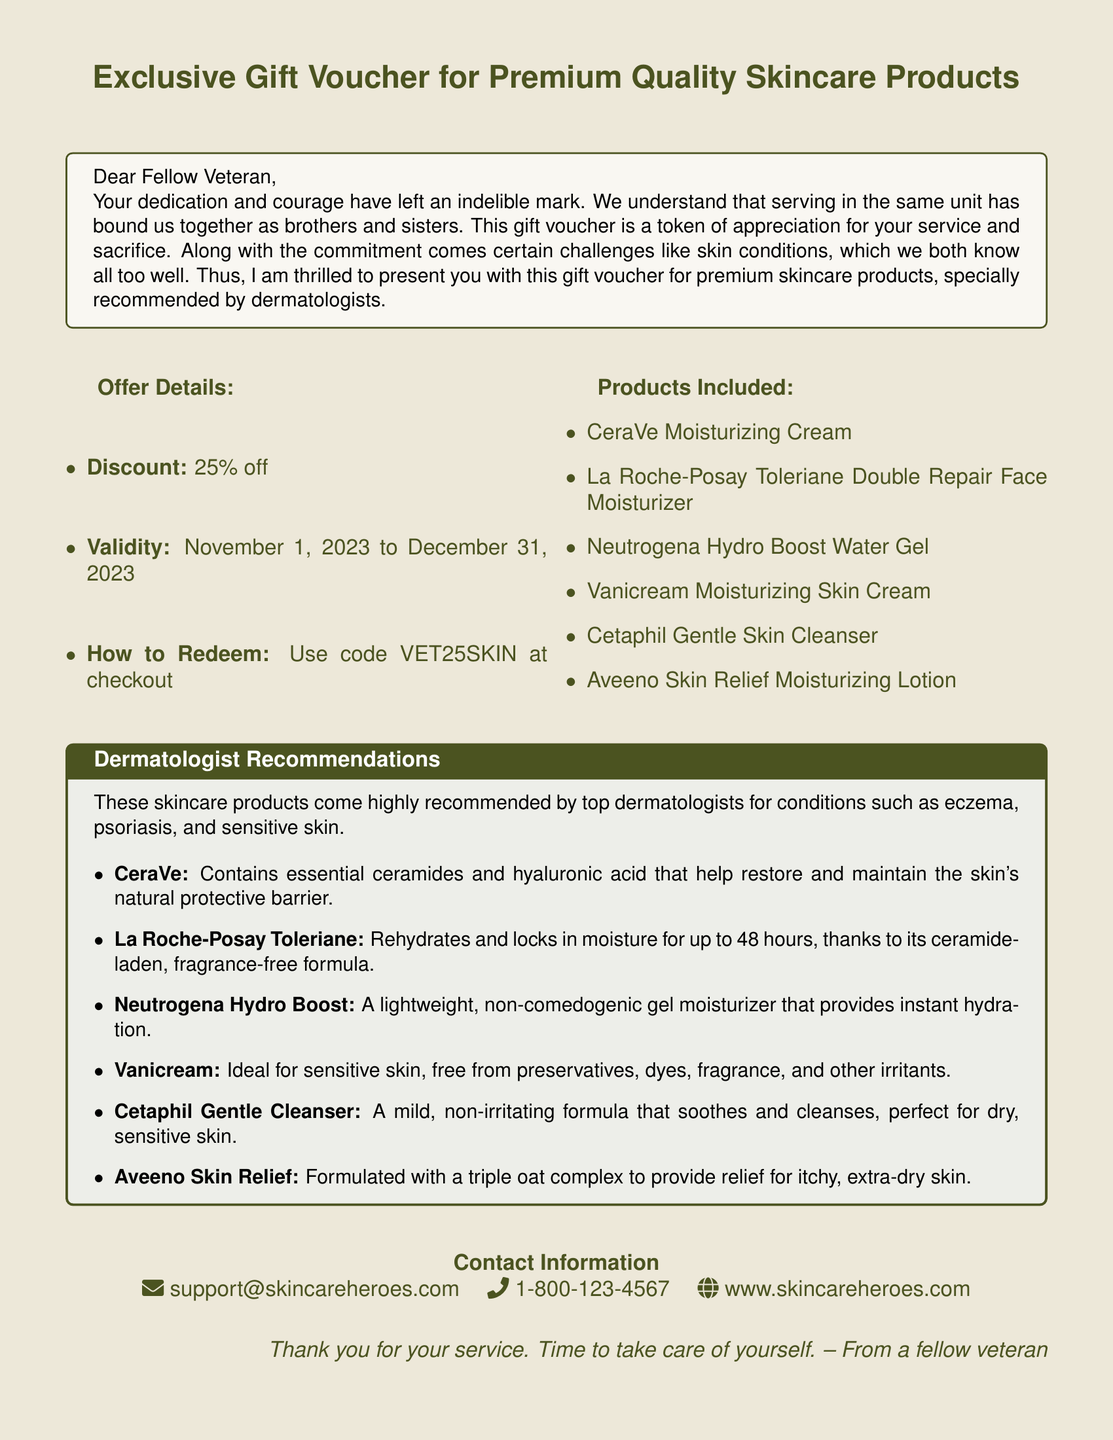what is the discount offered? The document states a discount of 25% off for the skincare products.
Answer: 25% off when does the voucher expire? The validity of the voucher is from November 1, 2023, to December 31, 2023.
Answer: December 31, 2023 which code is used to redeem the voucher? The code provided in the document to use at checkout is VET25SKIN.
Answer: VET25SKIN how many products are included in the offer? The document lists six different skincare products included in the offer.
Answer: Six what type of skin conditions are mentioned for product recommendations? The dermatologist recommendations focus on conditions such as eczema and psoriasis.
Answer: Eczema, psoriasis what is the contact email provided in the document? The document specifies the contact email for support as support@skincareheroes.com.
Answer: support@skincareheroes.com who is the gift voucher from? The document indicates that the gift voucher is from a fellow veteran.
Answer: A fellow veteran what is one product recommended for sensitive skin? The document mentions Vanicream as an ideal option for sensitive skin.
Answer: Vanicream 